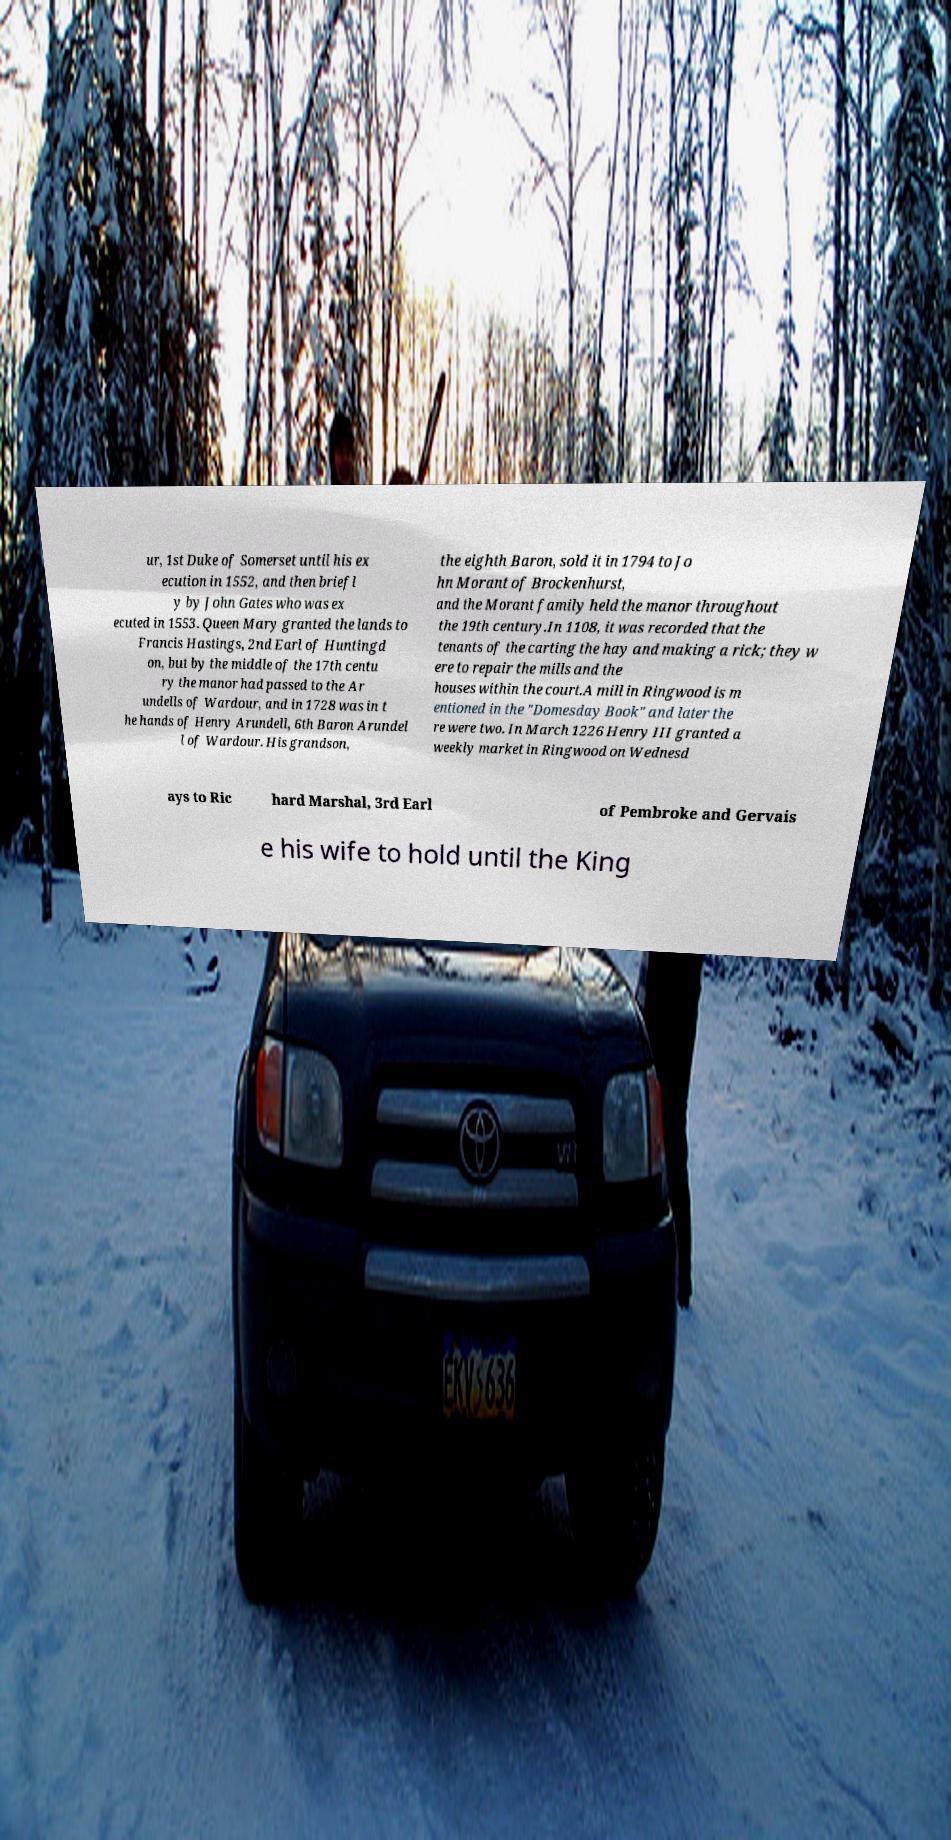Could you assist in decoding the text presented in this image and type it out clearly? ur, 1st Duke of Somerset until his ex ecution in 1552, and then briefl y by John Gates who was ex ecuted in 1553. Queen Mary granted the lands to Francis Hastings, 2nd Earl of Huntingd on, but by the middle of the 17th centu ry the manor had passed to the Ar undells of Wardour, and in 1728 was in t he hands of Henry Arundell, 6th Baron Arundel l of Wardour. His grandson, the eighth Baron, sold it in 1794 to Jo hn Morant of Brockenhurst, and the Morant family held the manor throughout the 19th century.In 1108, it was recorded that the tenants of the carting the hay and making a rick; they w ere to repair the mills and the houses within the court.A mill in Ringwood is m entioned in the "Domesday Book" and later the re were two. In March 1226 Henry III granted a weekly market in Ringwood on Wednesd ays to Ric hard Marshal, 3rd Earl of Pembroke and Gervais e his wife to hold until the King 